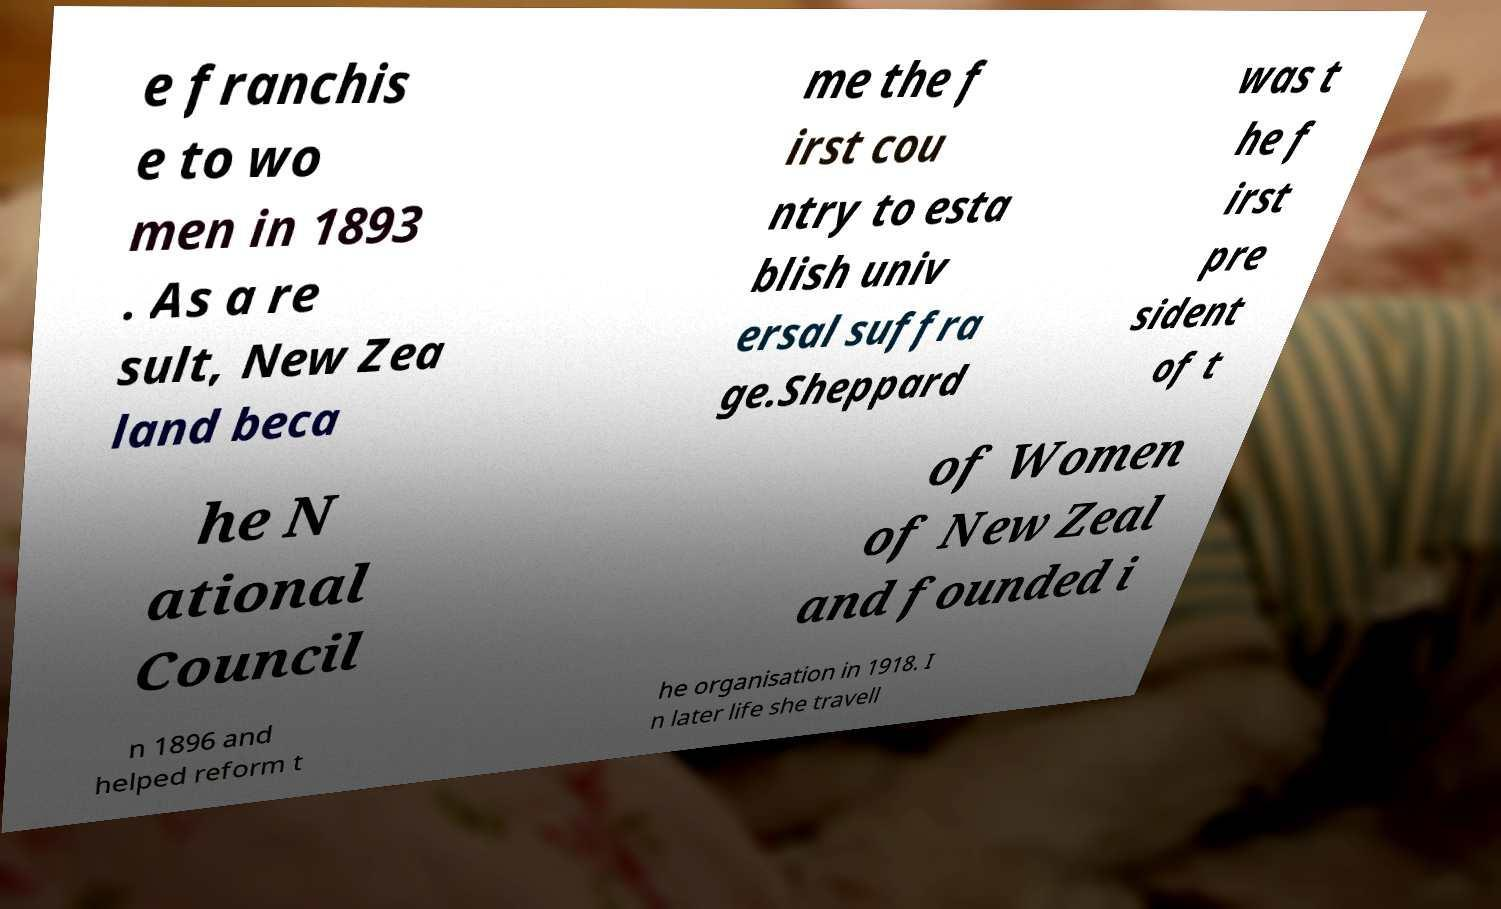Can you accurately transcribe the text from the provided image for me? e franchis e to wo men in 1893 . As a re sult, New Zea land beca me the f irst cou ntry to esta blish univ ersal suffra ge.Sheppard was t he f irst pre sident of t he N ational Council of Women of New Zeal and founded i n 1896 and helped reform t he organisation in 1918. I n later life she travell 